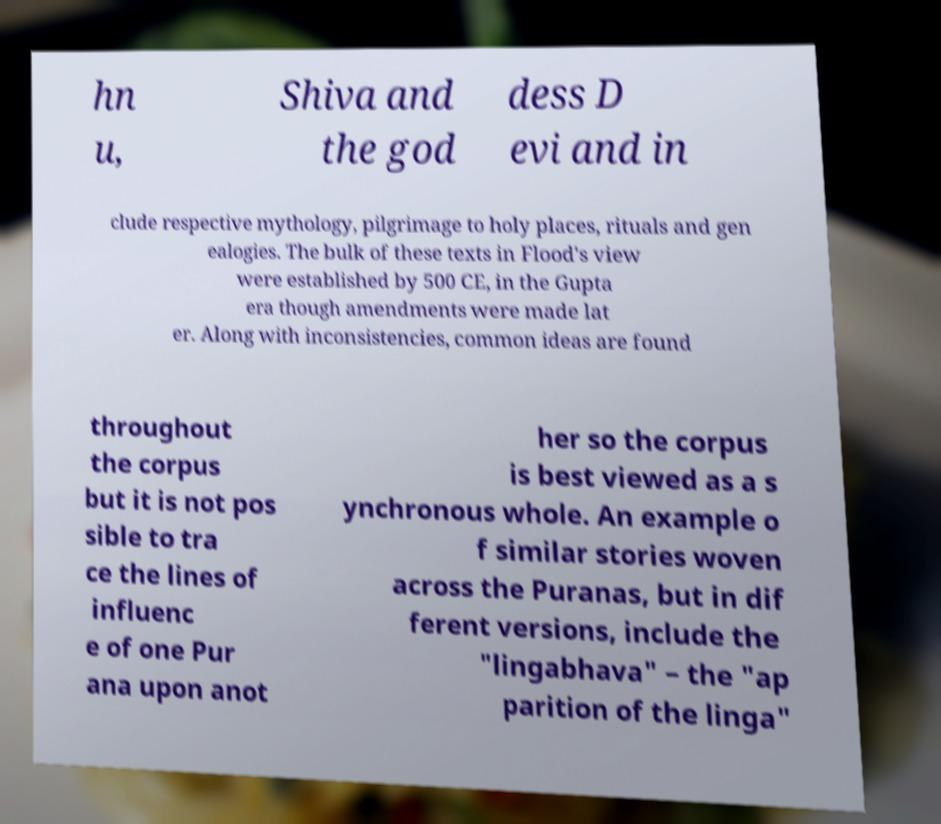Please identify and transcribe the text found in this image. hn u, Shiva and the god dess D evi and in clude respective mythology, pilgrimage to holy places, rituals and gen ealogies. The bulk of these texts in Flood's view were established by 500 CE, in the Gupta era though amendments were made lat er. Along with inconsistencies, common ideas are found throughout the corpus but it is not pos sible to tra ce the lines of influenc e of one Pur ana upon anot her so the corpus is best viewed as a s ynchronous whole. An example o f similar stories woven across the Puranas, but in dif ferent versions, include the "lingabhava" – the "ap parition of the linga" 